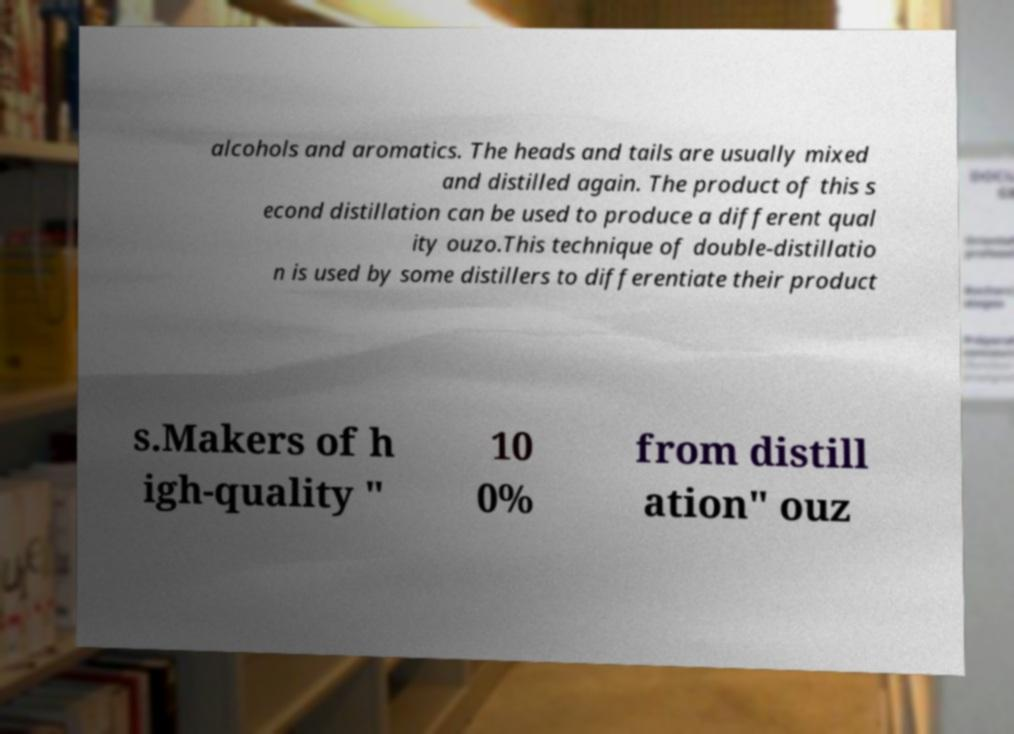Can you accurately transcribe the text from the provided image for me? alcohols and aromatics. The heads and tails are usually mixed and distilled again. The product of this s econd distillation can be used to produce a different qual ity ouzo.This technique of double-distillatio n is used by some distillers to differentiate their product s.Makers of h igh-quality " 10 0% from distill ation" ouz 